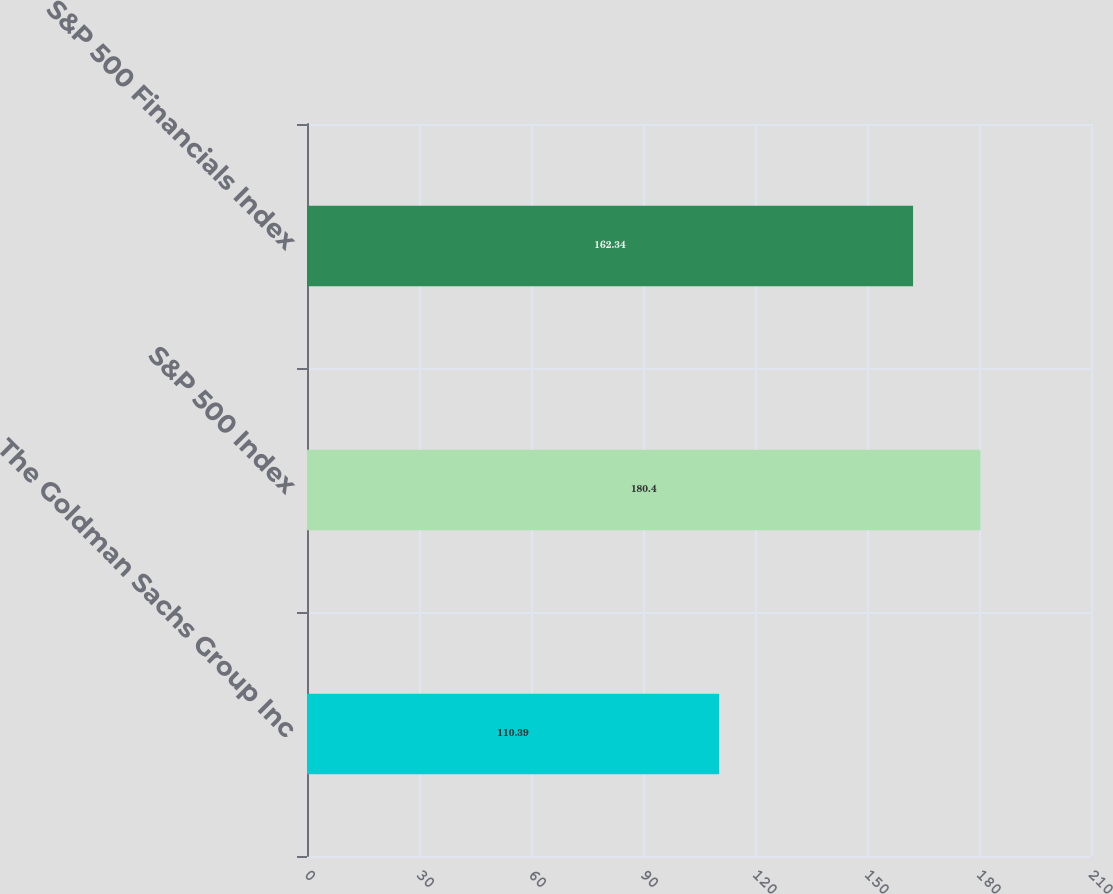Convert chart. <chart><loc_0><loc_0><loc_500><loc_500><bar_chart><fcel>The Goldman Sachs Group Inc<fcel>S&P 500 Index<fcel>S&P 500 Financials Index<nl><fcel>110.39<fcel>180.4<fcel>162.34<nl></chart> 